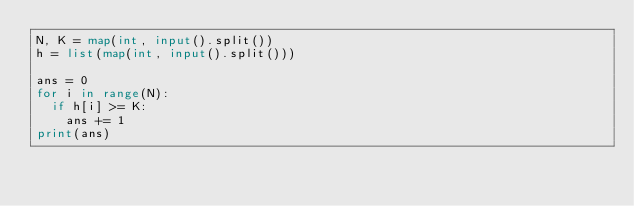<code> <loc_0><loc_0><loc_500><loc_500><_Python_>N, K = map(int, input().split())
h = list(map(int, input().split()))

ans = 0
for i in range(N):
  if h[i] >= K:
    ans += 1
print(ans)</code> 